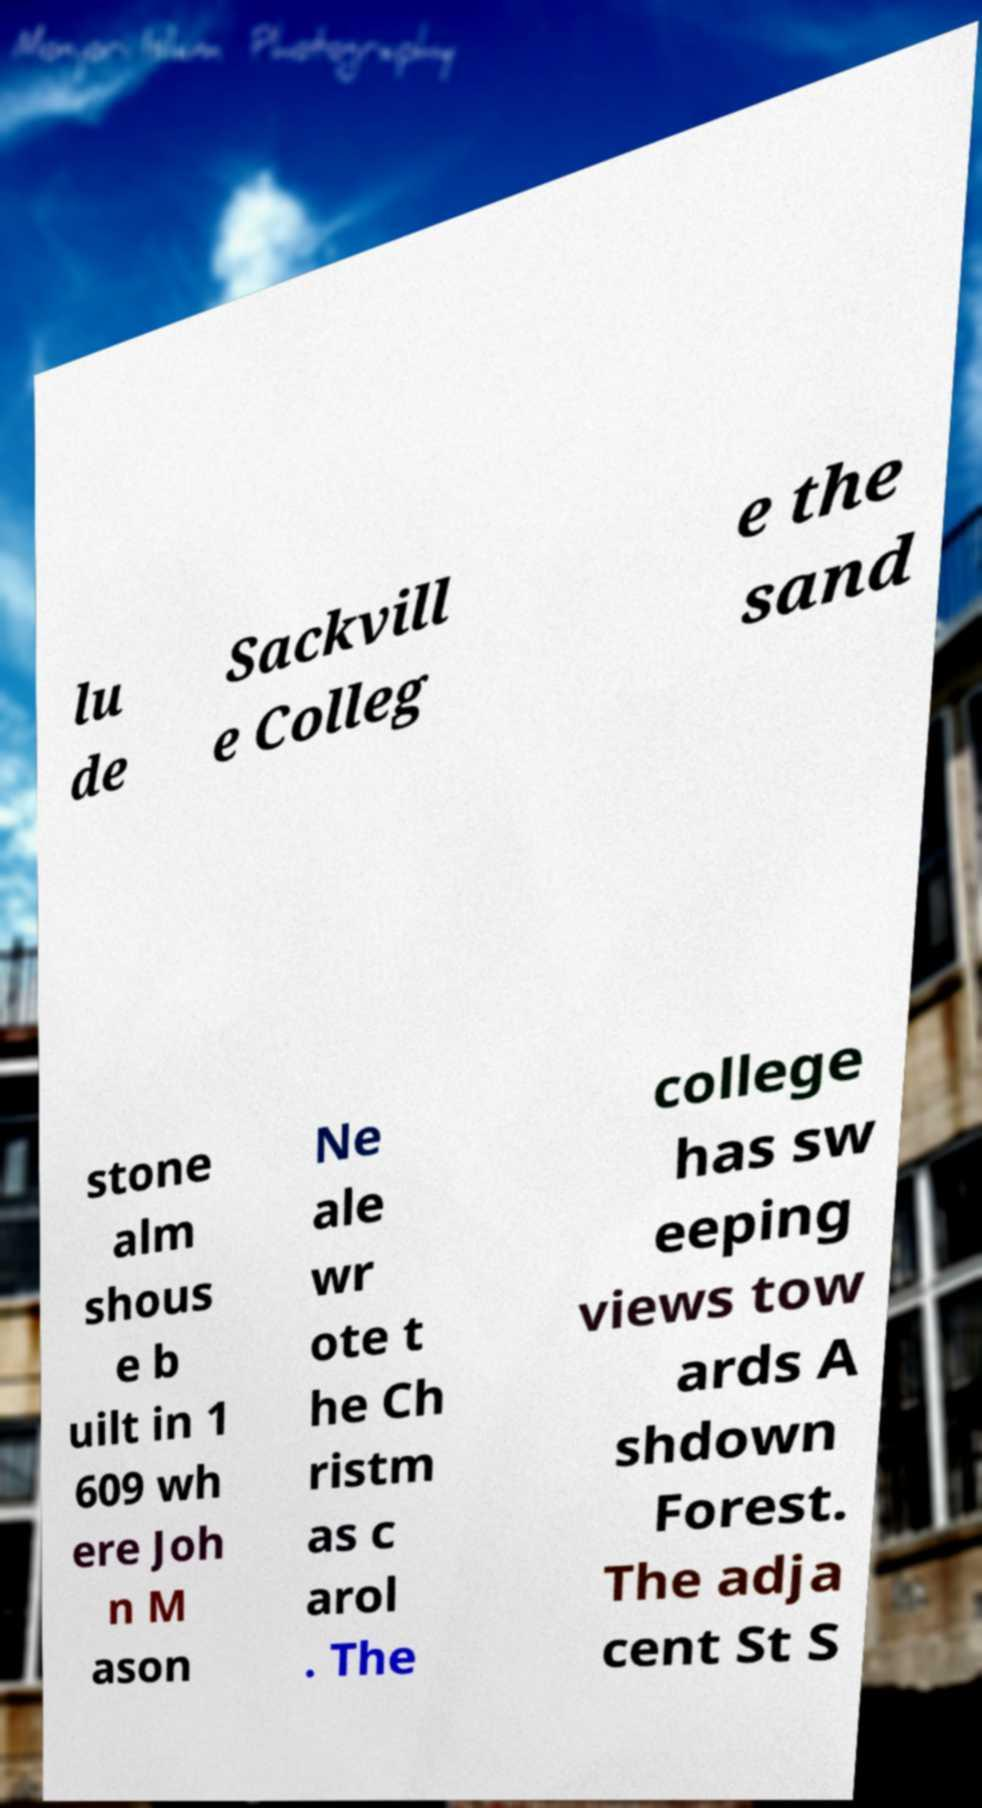For documentation purposes, I need the text within this image transcribed. Could you provide that? lu de Sackvill e Colleg e the sand stone alm shous e b uilt in 1 609 wh ere Joh n M ason Ne ale wr ote t he Ch ristm as c arol . The college has sw eeping views tow ards A shdown Forest. The adja cent St S 